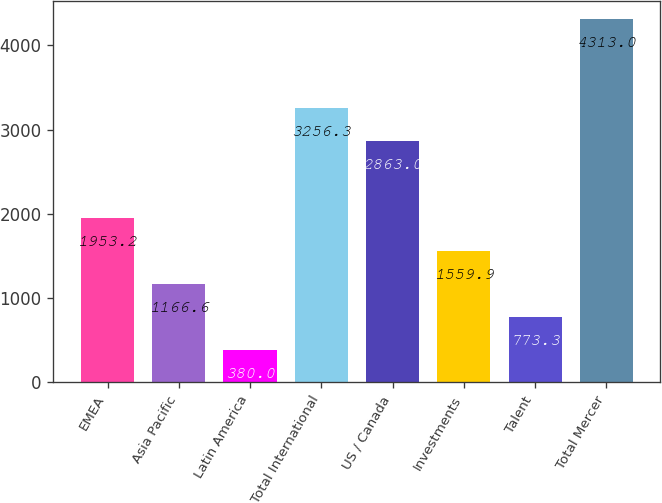Convert chart. <chart><loc_0><loc_0><loc_500><loc_500><bar_chart><fcel>EMEA<fcel>Asia Pacific<fcel>Latin America<fcel>Total International<fcel>US / Canada<fcel>Investments<fcel>Talent<fcel>Total Mercer<nl><fcel>1953.2<fcel>1166.6<fcel>380<fcel>3256.3<fcel>2863<fcel>1559.9<fcel>773.3<fcel>4313<nl></chart> 